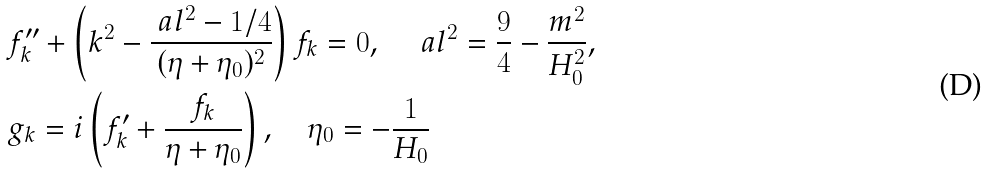Convert formula to latex. <formula><loc_0><loc_0><loc_500><loc_500>& f _ { k } ^ { \prime \prime } + \left ( k ^ { 2 } - \frac { \ a l ^ { 2 } - 1 / 4 } { ( \eta + \eta _ { 0 } ) ^ { 2 } } \right ) f _ { k } = 0 , \quad \ a l ^ { 2 } = \frac { 9 } { 4 } - \frac { m ^ { 2 } } { H _ { 0 } ^ { 2 } } , \\ & g _ { k } = i \left ( f _ { k } ^ { \prime } + \frac { f _ { k } } { \eta + \eta _ { 0 } } \right ) , \quad \eta _ { 0 } = - \frac { 1 } { H _ { 0 } }</formula> 